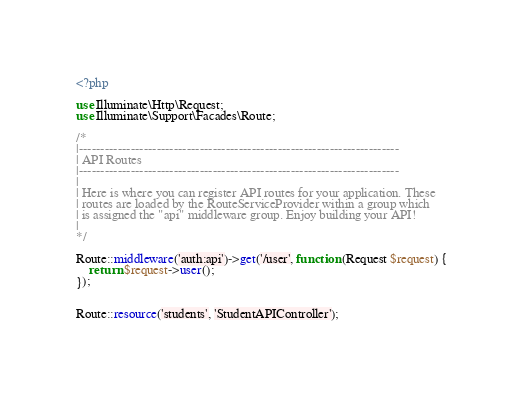Convert code to text. <code><loc_0><loc_0><loc_500><loc_500><_PHP_><?php

use Illuminate\Http\Request;
use Illuminate\Support\Facades\Route;

/*
|--------------------------------------------------------------------------
| API Routes
|--------------------------------------------------------------------------
|
| Here is where you can register API routes for your application. These
| routes are loaded by the RouteServiceProvider within a group which
| is assigned the "api" middleware group. Enjoy building your API!
|
*/

Route::middleware('auth:api')->get('/user', function (Request $request) {
    return $request->user();
});


Route::resource('students', 'StudentAPIController');</code> 